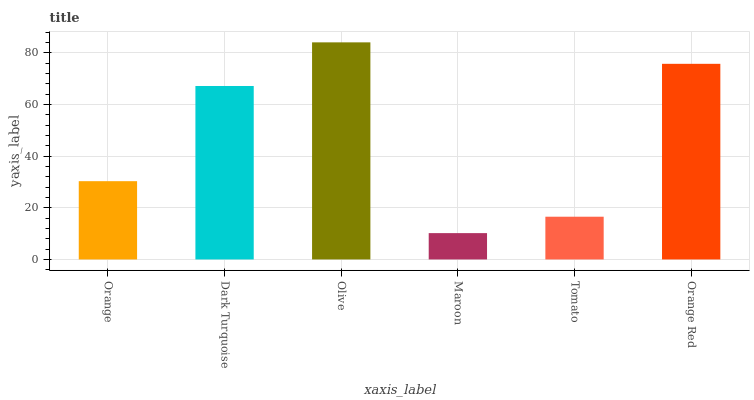Is Maroon the minimum?
Answer yes or no. Yes. Is Olive the maximum?
Answer yes or no. Yes. Is Dark Turquoise the minimum?
Answer yes or no. No. Is Dark Turquoise the maximum?
Answer yes or no. No. Is Dark Turquoise greater than Orange?
Answer yes or no. Yes. Is Orange less than Dark Turquoise?
Answer yes or no. Yes. Is Orange greater than Dark Turquoise?
Answer yes or no. No. Is Dark Turquoise less than Orange?
Answer yes or no. No. Is Dark Turquoise the high median?
Answer yes or no. Yes. Is Orange the low median?
Answer yes or no. Yes. Is Orange Red the high median?
Answer yes or no. No. Is Olive the low median?
Answer yes or no. No. 